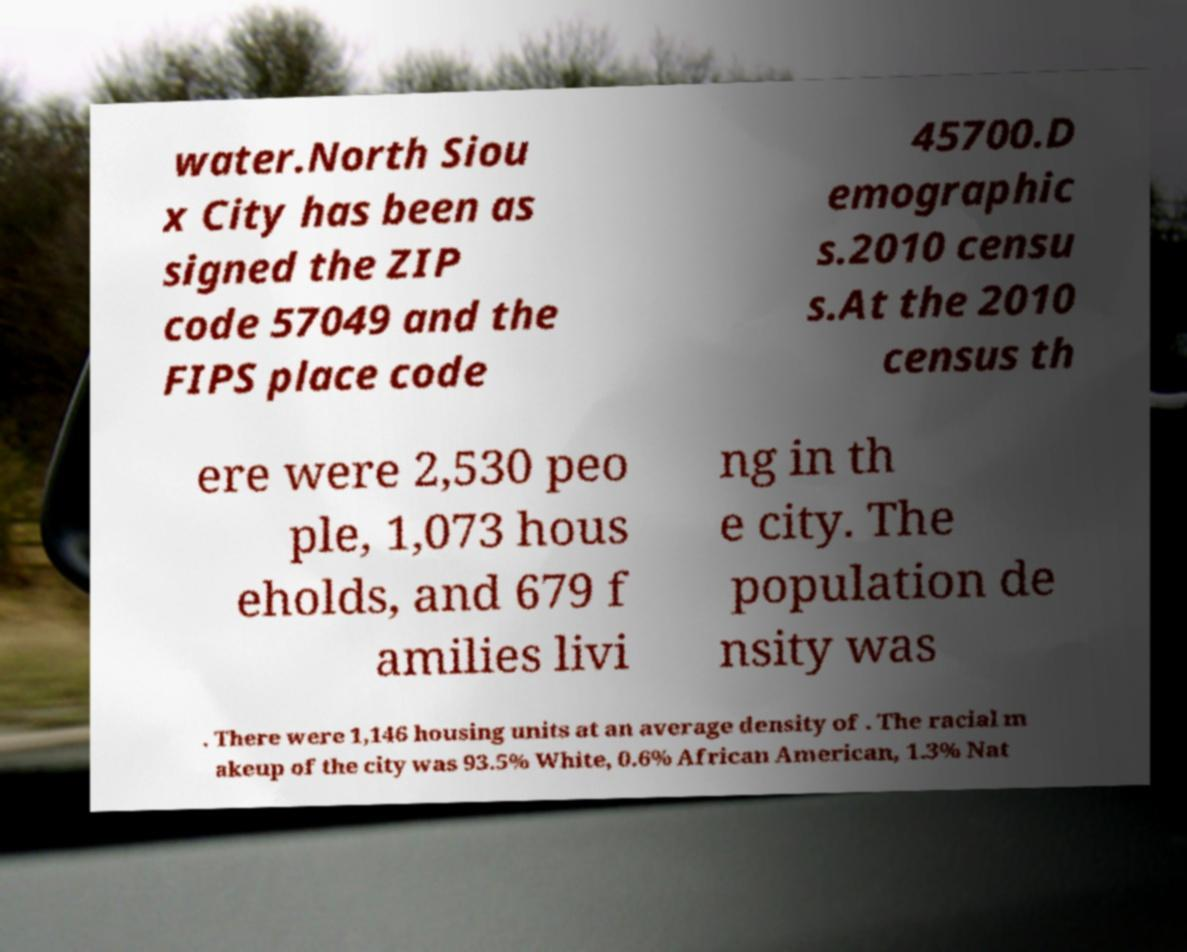Please identify and transcribe the text found in this image. water.North Siou x City has been as signed the ZIP code 57049 and the FIPS place code 45700.D emographic s.2010 censu s.At the 2010 census th ere were 2,530 peo ple, 1,073 hous eholds, and 679 f amilies livi ng in th e city. The population de nsity was . There were 1,146 housing units at an average density of . The racial m akeup of the city was 93.5% White, 0.6% African American, 1.3% Nat 